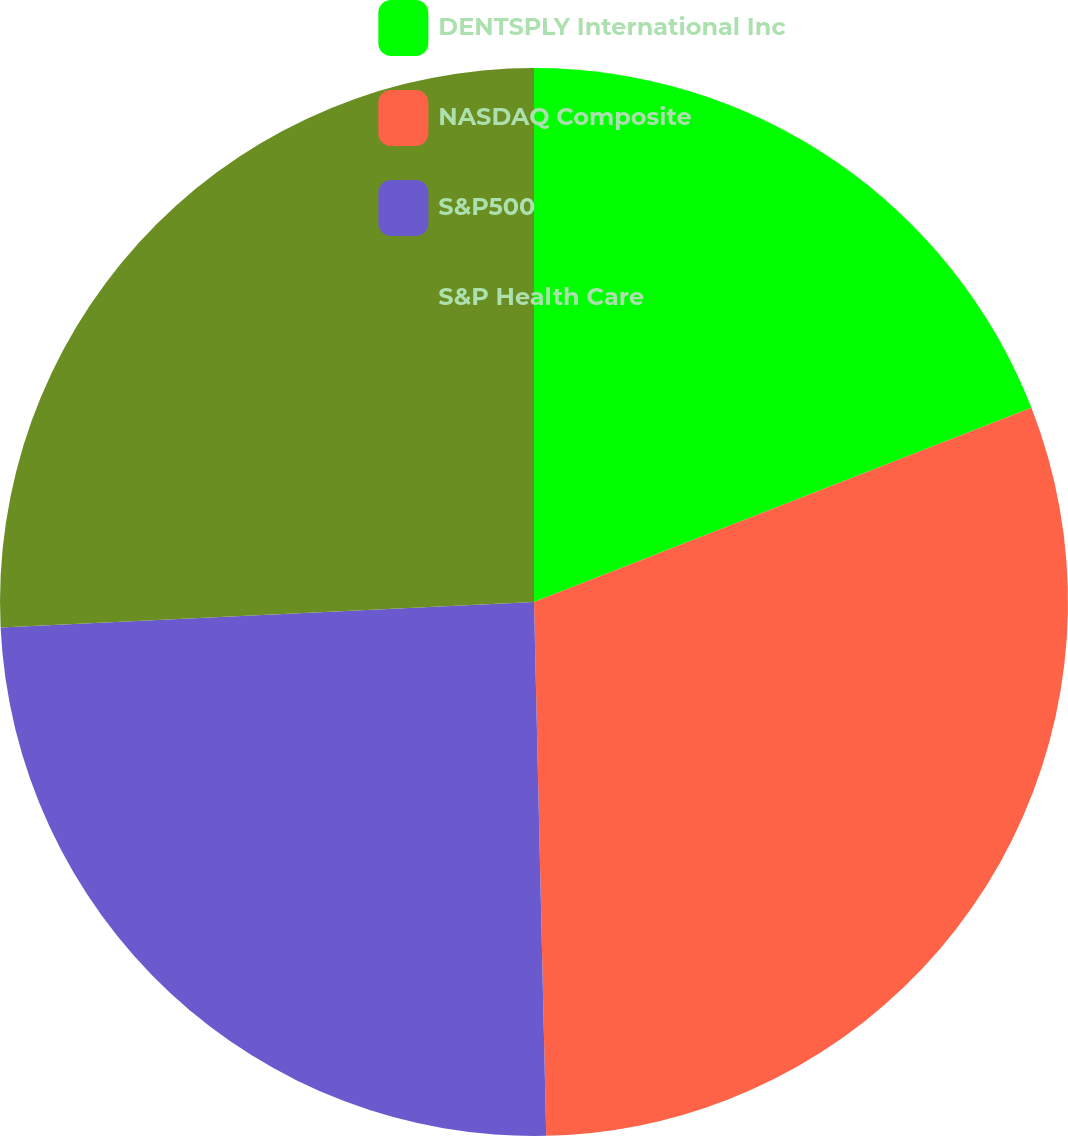Convert chart to OTSL. <chart><loc_0><loc_0><loc_500><loc_500><pie_chart><fcel>DENTSPLY International Inc<fcel>NASDAQ Composite<fcel>S&P500<fcel>S&P Health Care<nl><fcel>19.08%<fcel>30.56%<fcel>24.61%<fcel>25.76%<nl></chart> 